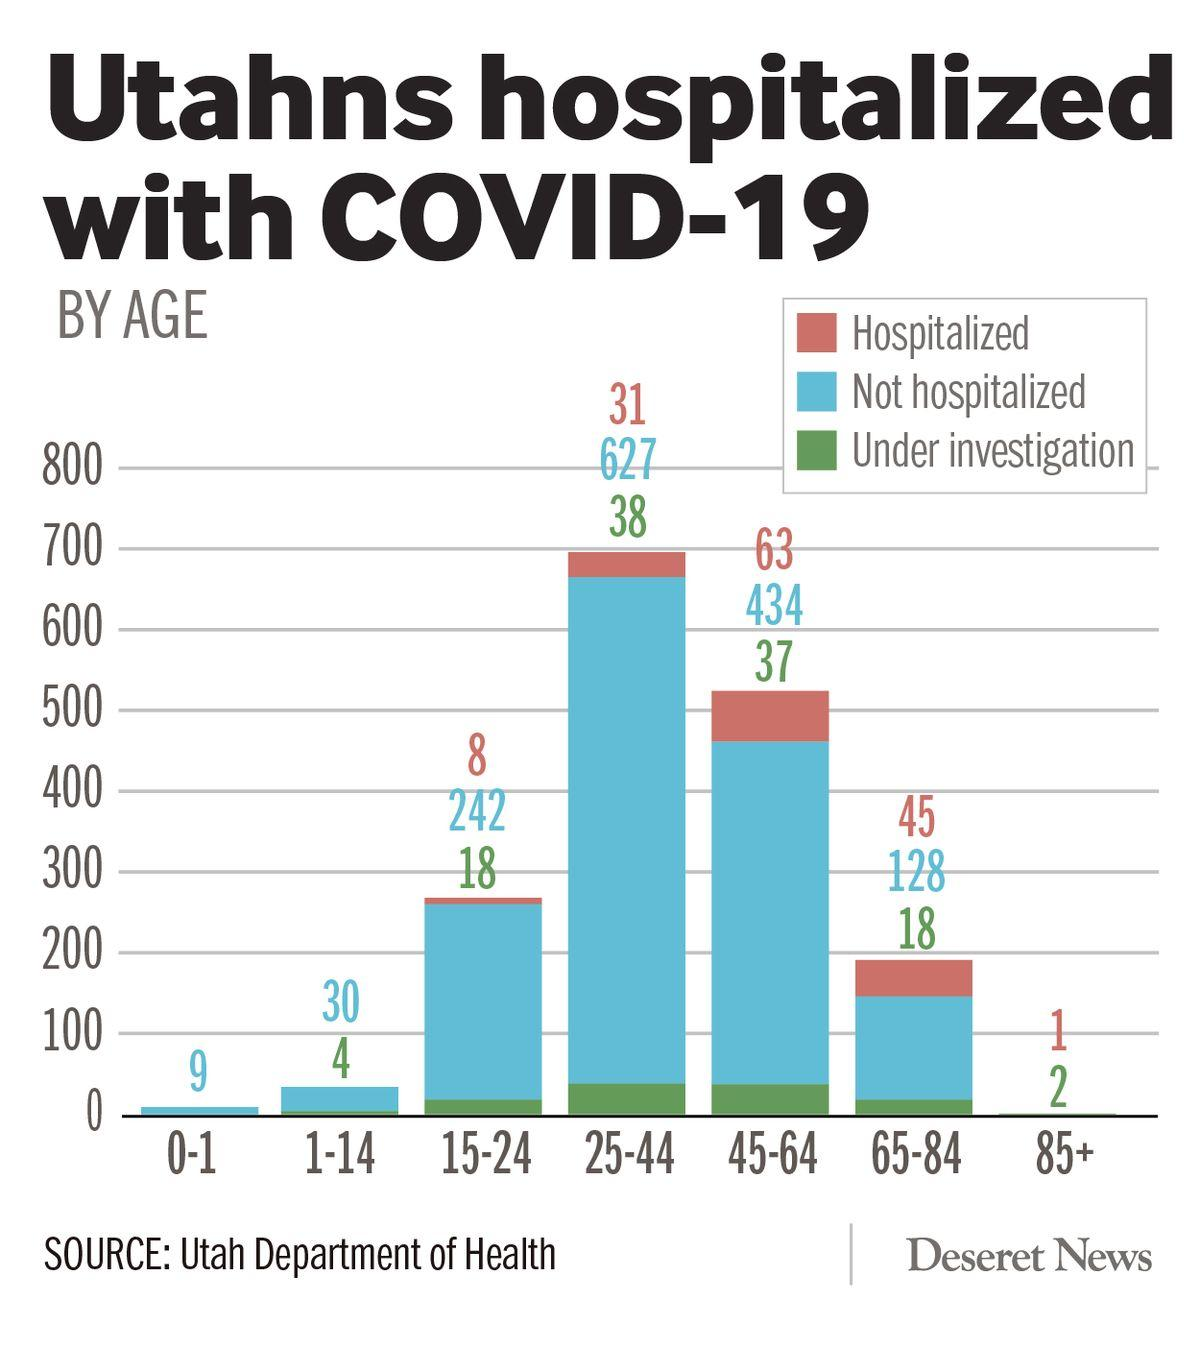Outline some significant characteristics in this image. The total number of individuals in the age group of 25-44 who were either hospitalized or not hospitalized is 658. The difference in hospitalization rates between the age group of 65-84 and 83 years old is unknown. The total number of hospitalized and not hospitalized individuals in the age group 45-64 is 497. The difference between being hospitalized and under investigation in the age group 45-64 is 26. The total number of people aged 45-64 who were hospitalized and those who are currently under investigation is 100. 